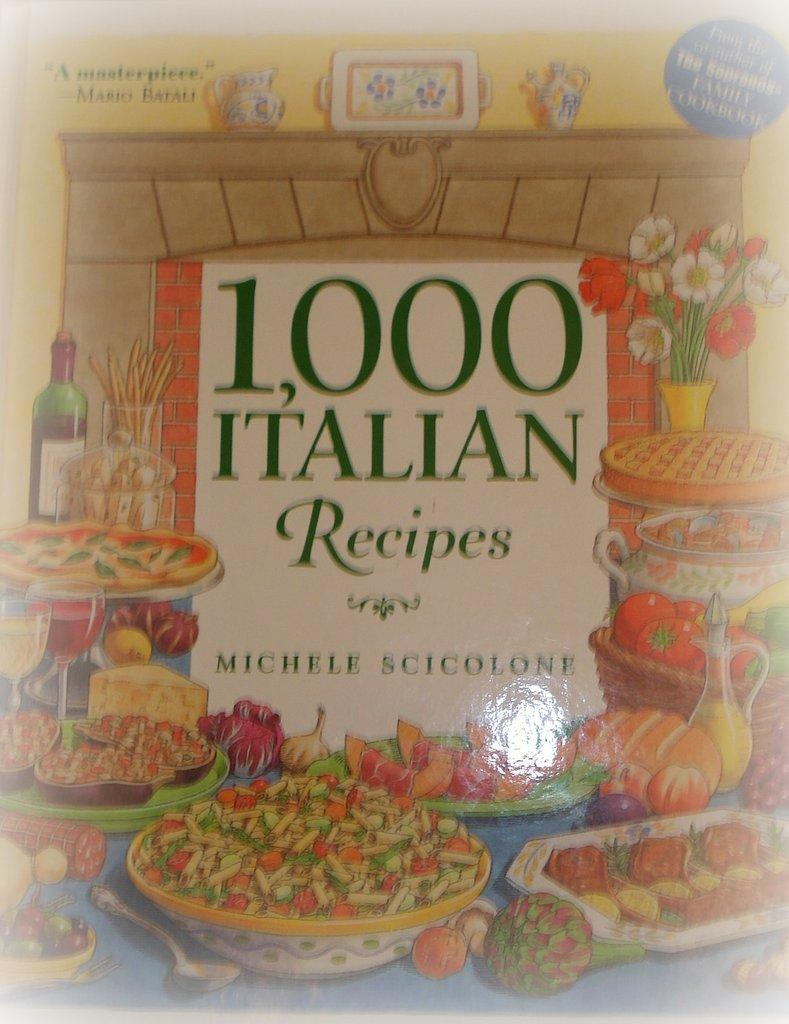<image>
Summarize the visual content of the image. the number 1000 is on the book with many recipes 